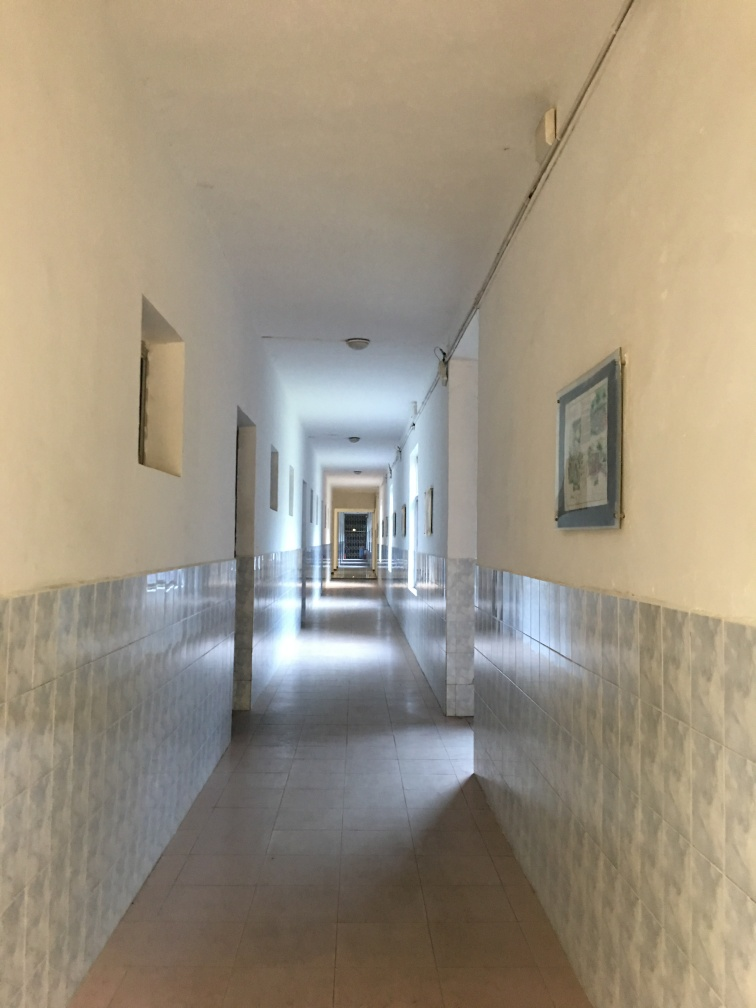Can you comment on the architectural design visible in the photo? The photo depicts a corridor with a symmetric perspective that draws the eye toward the end of the hallway. The use of tiling halfway up the wall, coupled with plain painted walls above, is characteristic of a functional design that is easy to maintain. This simplicity is broken by periodic wall-mounted light fixtures and framed artwork, adding functional and aesthetic elements to the space. 